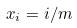<formula> <loc_0><loc_0><loc_500><loc_500>x _ { i } = i / m</formula> 